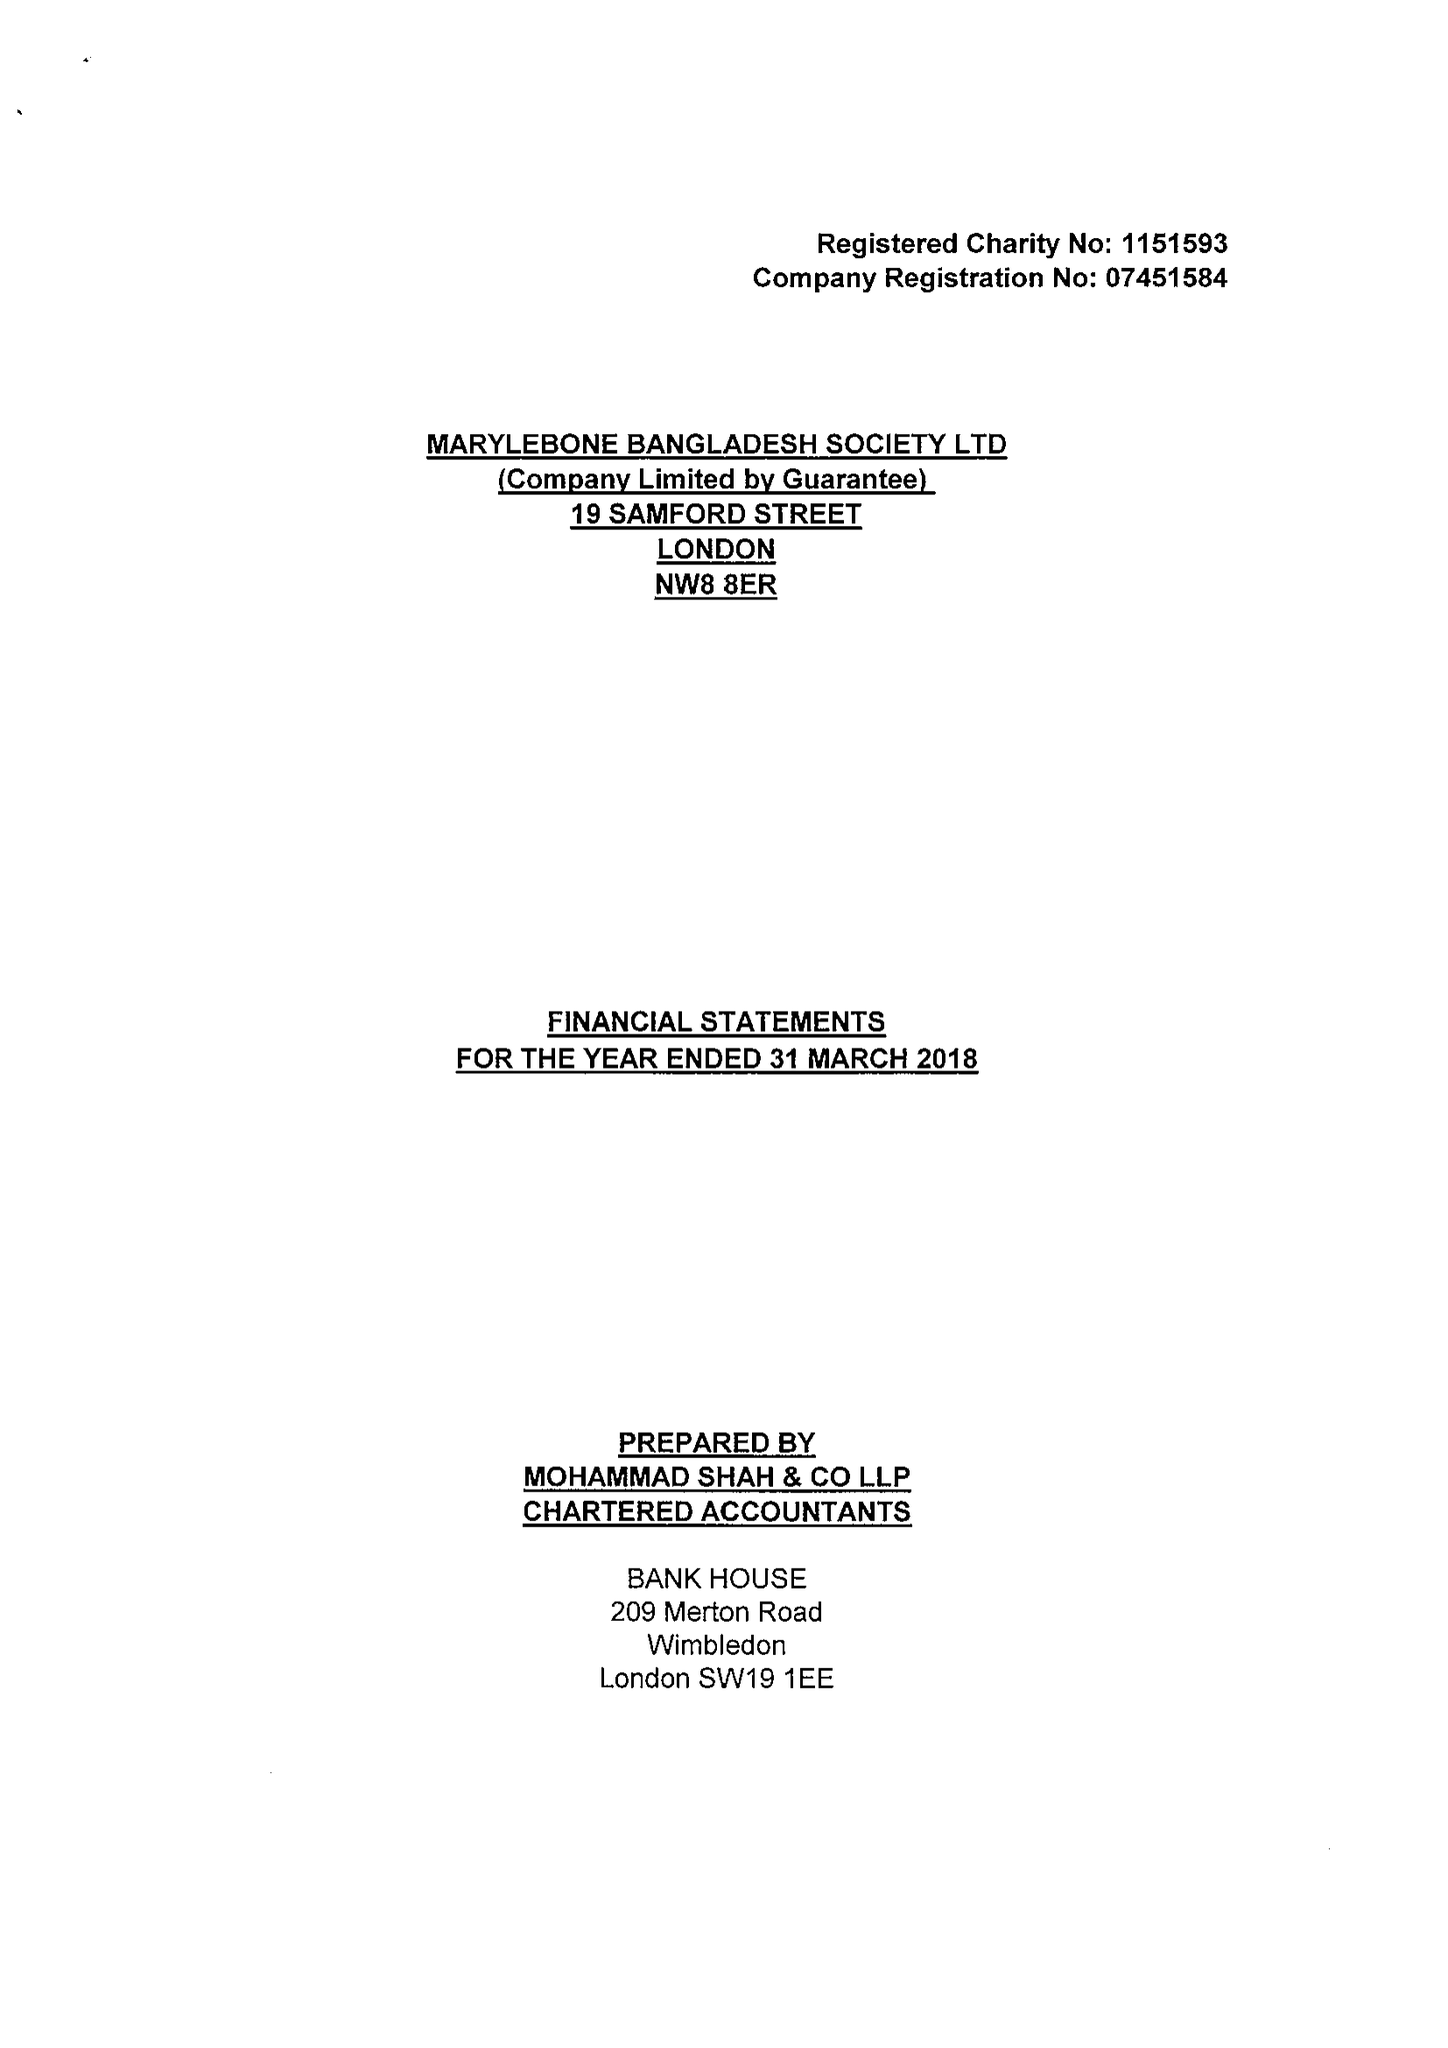What is the value for the address__street_line?
Answer the question using a single word or phrase. 19 SAMFORD STREET 